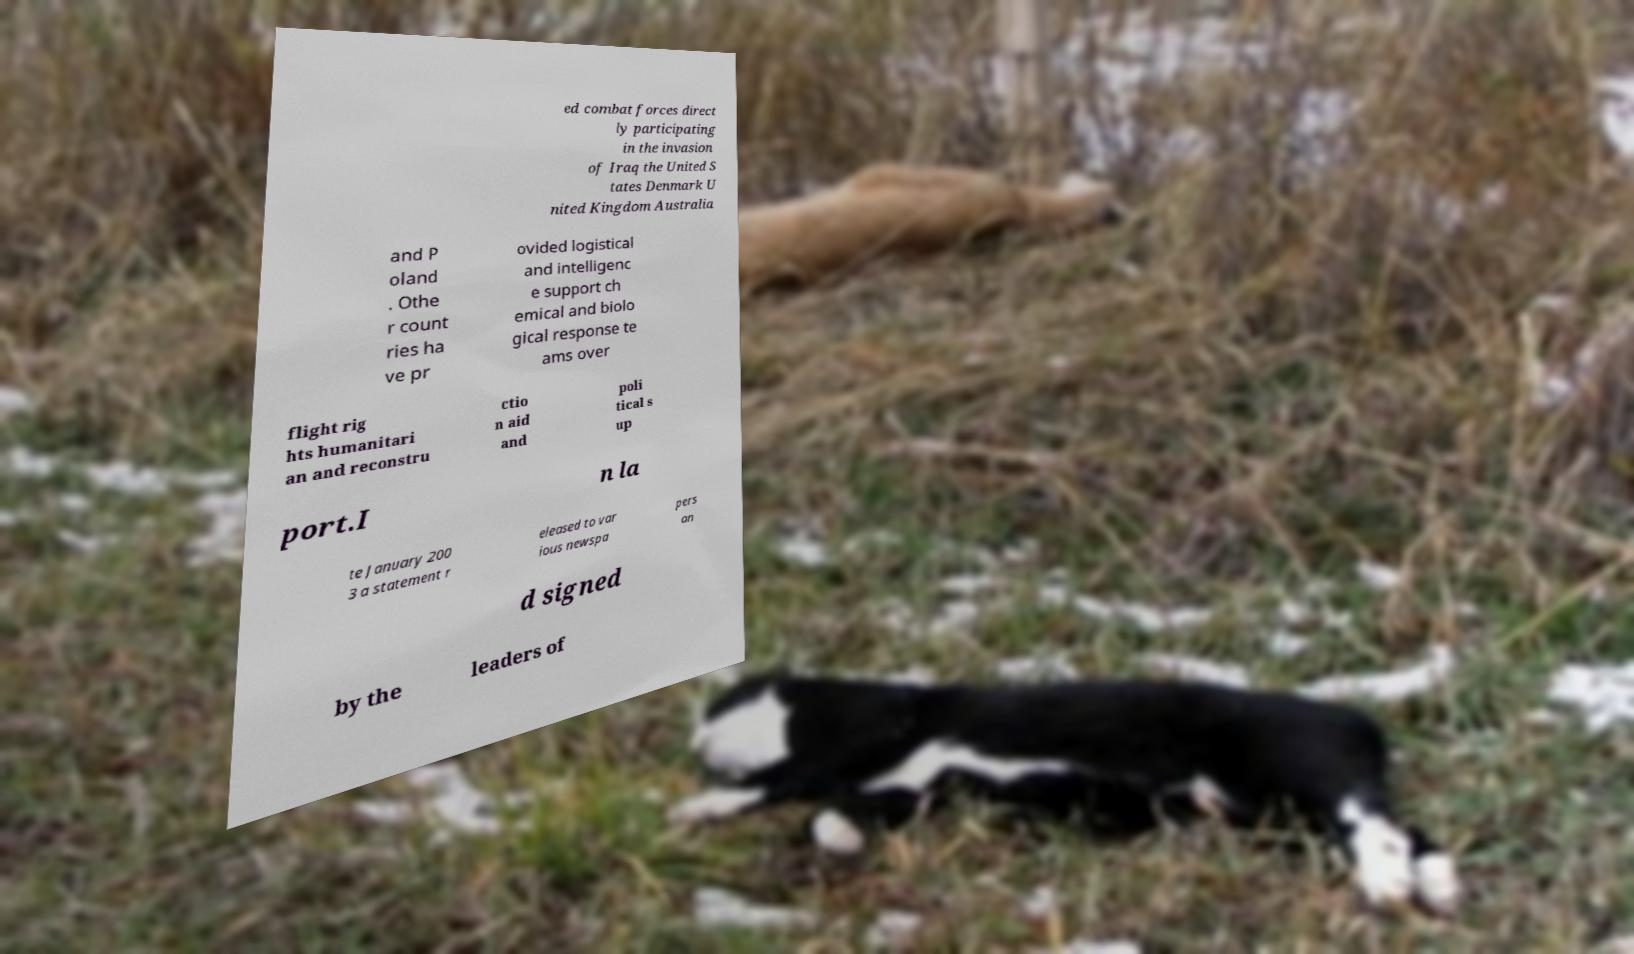For documentation purposes, I need the text within this image transcribed. Could you provide that? ed combat forces direct ly participating in the invasion of Iraq the United S tates Denmark U nited Kingdom Australia and P oland . Othe r count ries ha ve pr ovided logistical and intelligenc e support ch emical and biolo gical response te ams over flight rig hts humanitari an and reconstru ctio n aid and poli tical s up port.I n la te January 200 3 a statement r eleased to var ious newspa pers an d signed by the leaders of 